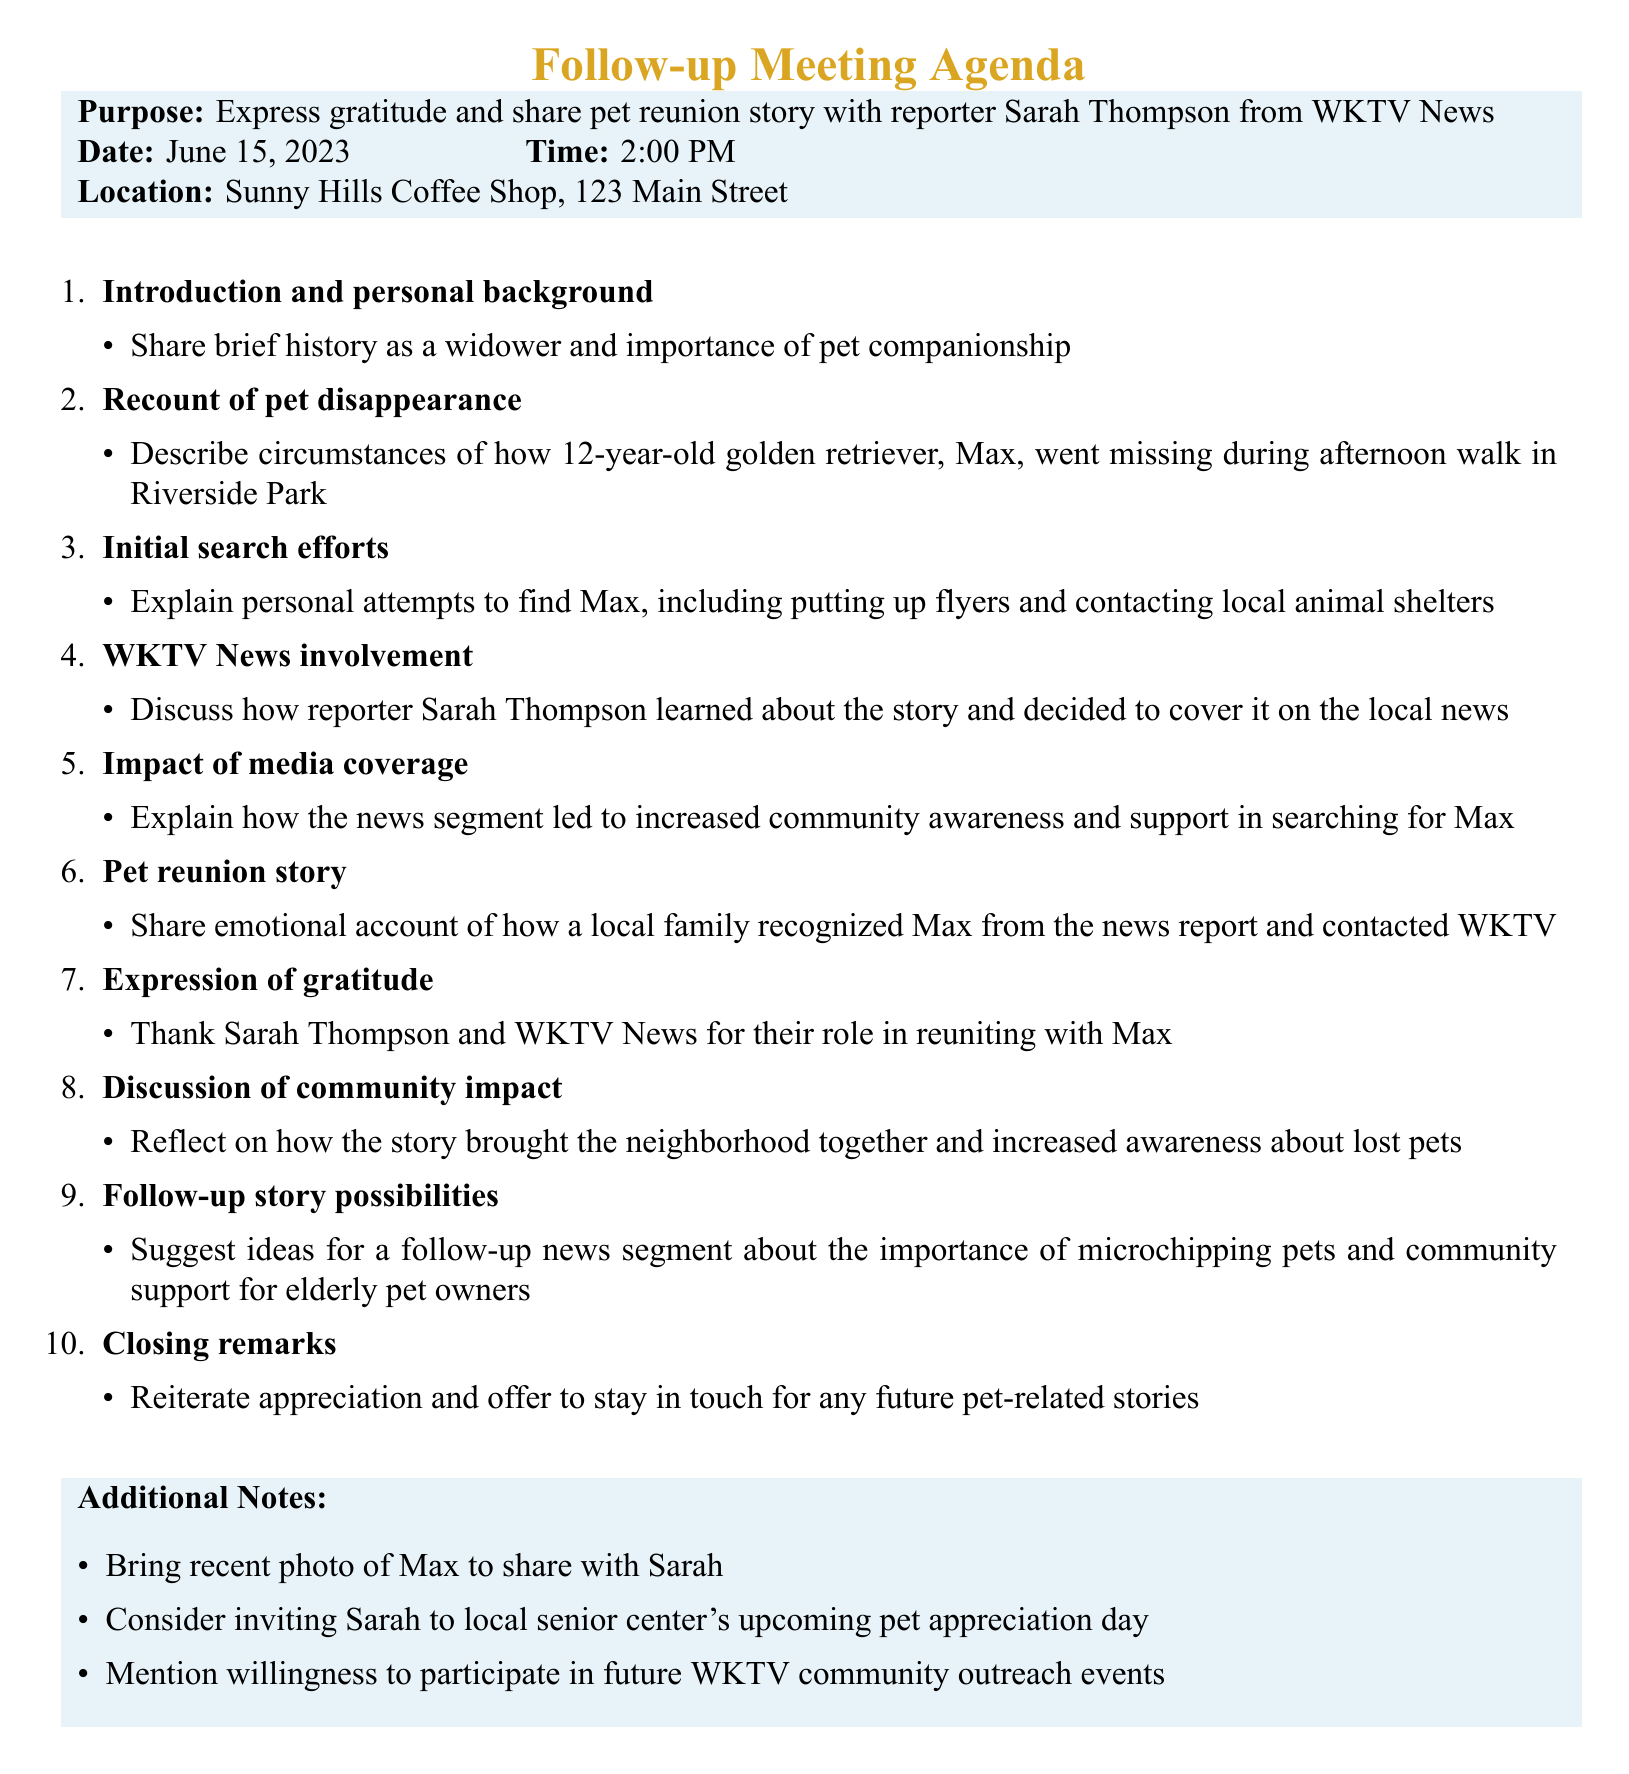What is the purpose of the meeting? The purpose of the meeting is stated clearly in the document as "Express gratitude and share pet reunion story with reporter Sarah Thompson from WKTV News."
Answer: Express gratitude and share pet reunion story with reporter Sarah Thompson from WKTV News When is the follow-up meeting scheduled? The document specifies the date of the meeting as "June 15, 2023."
Answer: June 15, 2023 What is the name of the reporter involved? The document mentions the reporter's name as "Sarah Thompson."
Answer: Sarah Thompson What is the location of the meeting? The meeting location is provided in the document as "Sunny Hills Coffee Shop, 123 Main Street."
Answer: Sunny Hills Coffee Shop, 123 Main Street What type of pet is Max? The document describes Max as a "12-year-old golden retriever."
Answer: 12-year-old golden retriever How did Sarah Thompson learn about the story? The document suggests discussing "how reporter Sarah Thompson learned about the story and decided to cover it on the local news."
Answer: How reporter Sarah Thompson learned about the story and decided to cover it on the local news What emotional account will be shared during the meeting? The agenda indicates that there will be a "share emotional account of how a local family recognized Max from the news report and contacted WKTV."
Answer: Share emotional account of how a local family recognized Max from the news report and contacted WKTV What additional notes are mentioned for the meeting? The document includes several additional notes, such as "Bring recent photo of Max to share with Sarah."
Answer: Bring recent photo of Max to share with Sarah What community impact is discussed? The document indicates a reflection on "how the story brought the neighborhood together and increased awareness about lost pets."
Answer: How the story brought the neighborhood together and increased awareness about lost pets 